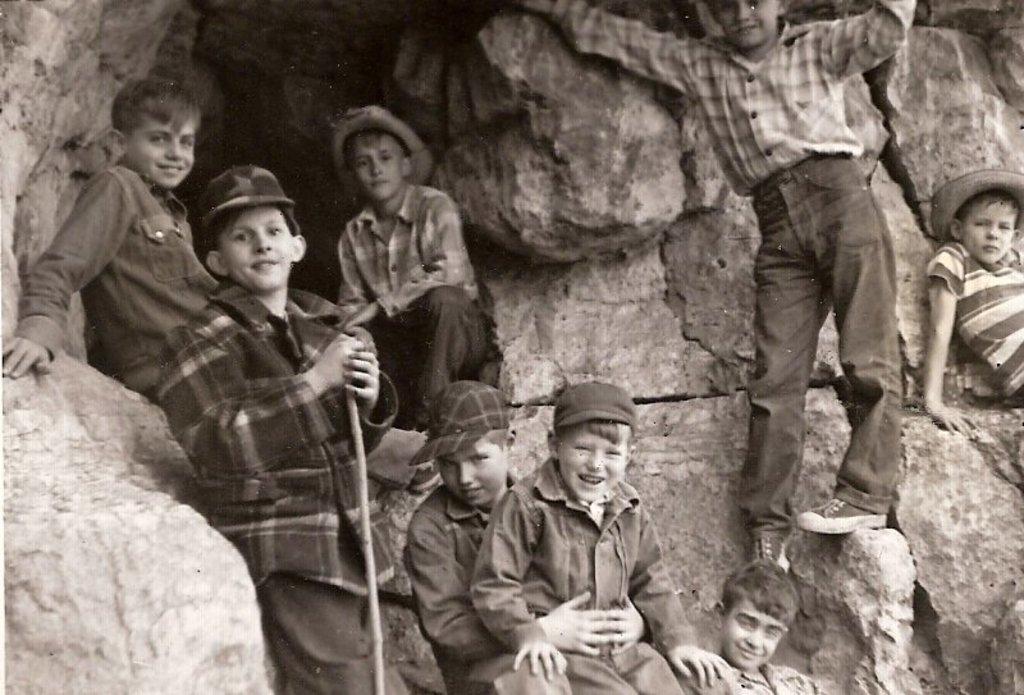How would you summarize this image in a sentence or two? This is a black and white pic. Here we can see few kids are sitting and standing on the stones and few of them wore caps on their heads and a kid is holding a stick in his hands. 